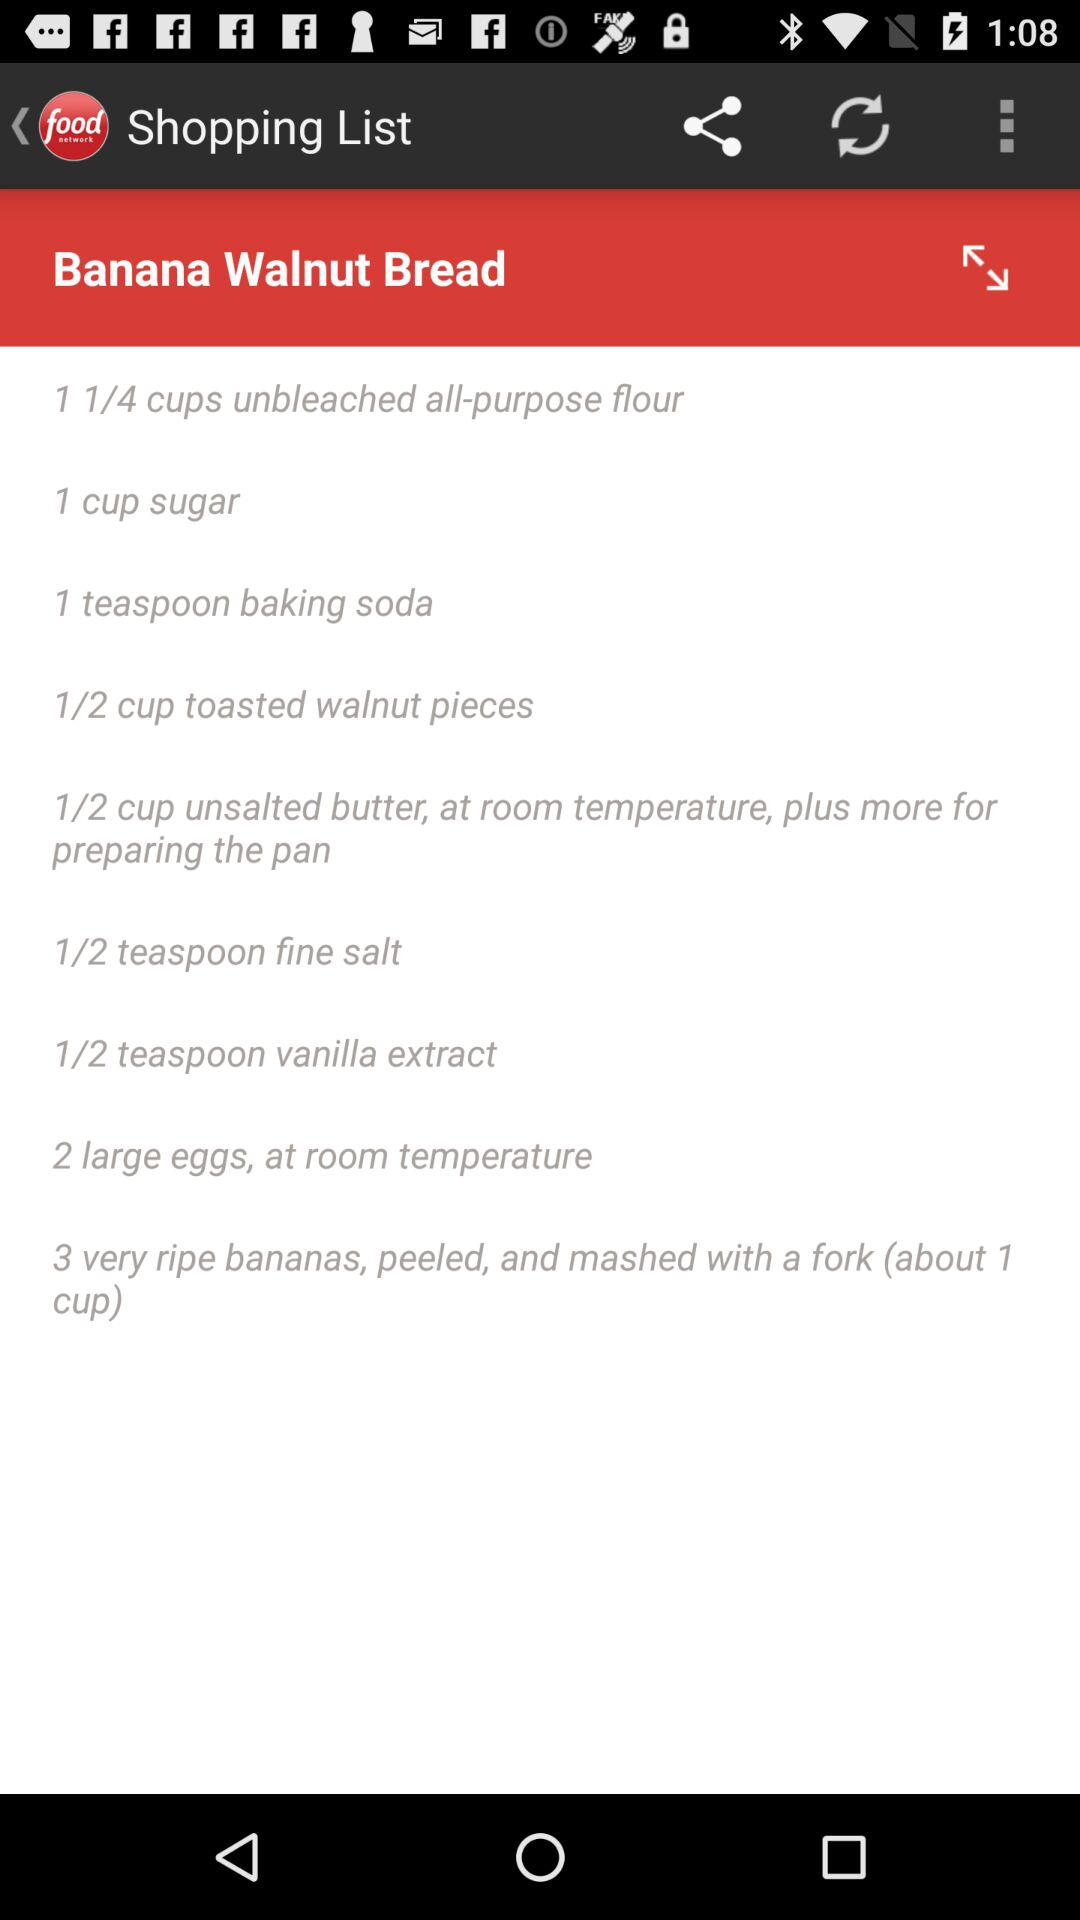How many ripe bananas are required? There is a requirement of 3 ripe bananas. 